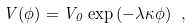<formula> <loc_0><loc_0><loc_500><loc_500>V ( \phi ) = V _ { 0 } \exp \left ( - \lambda \kappa \phi \right ) \ ,</formula> 